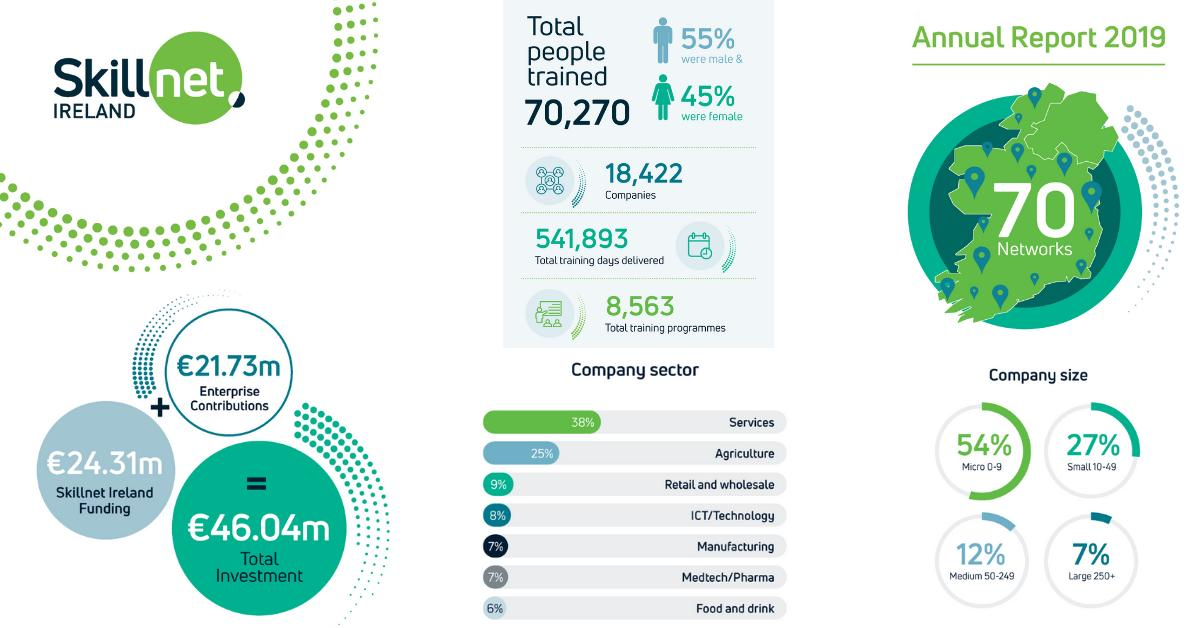Draw attention to some important aspects in this diagram. According to the 2019 annual report, 55% of the total number of trained people in Ireland were male. According to the Skillnet Ireland's 2019 annual report, the fund raised by the organization was €24.31 million. In 2019, 45% of the total number of trained people in Ireland were female, according to the annual report. 